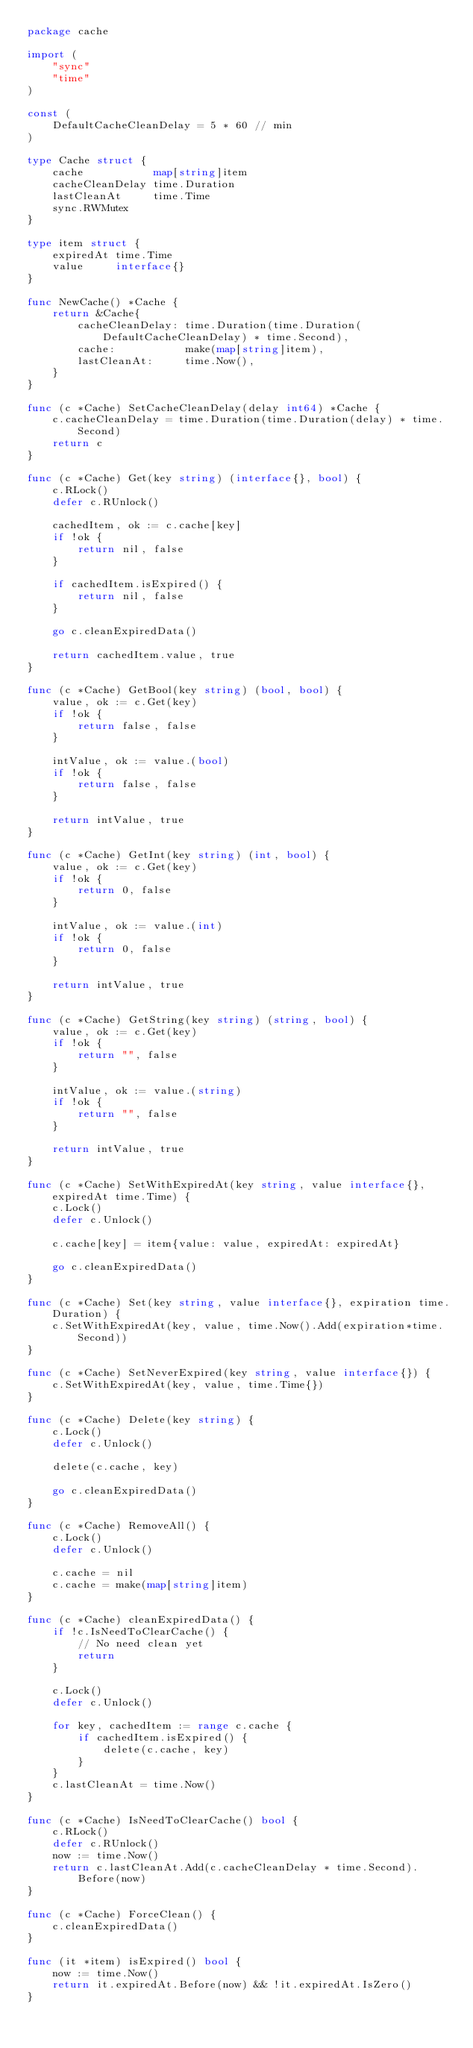Convert code to text. <code><loc_0><loc_0><loc_500><loc_500><_Go_>package cache

import (
	"sync"
	"time"
)

const (
	DefaultCacheCleanDelay = 5 * 60 // min
)

type Cache struct {
	cache           map[string]item
	cacheCleanDelay time.Duration
	lastCleanAt     time.Time
	sync.RWMutex
}

type item struct {
	expiredAt time.Time
	value     interface{}
}

func NewCache() *Cache {
	return &Cache{
		cacheCleanDelay: time.Duration(time.Duration(DefaultCacheCleanDelay) * time.Second),
		cache:           make(map[string]item),
		lastCleanAt:     time.Now(),
	}
}

func (c *Cache) SetCacheCleanDelay(delay int64) *Cache {
	c.cacheCleanDelay = time.Duration(time.Duration(delay) * time.Second)
	return c
}

func (c *Cache) Get(key string) (interface{}, bool) {
	c.RLock()
	defer c.RUnlock()

	cachedItem, ok := c.cache[key]
	if !ok {
		return nil, false
	}

	if cachedItem.isExpired() {
		return nil, false
	}

	go c.cleanExpiredData()

	return cachedItem.value, true
}

func (c *Cache) GetBool(key string) (bool, bool) {
	value, ok := c.Get(key)
	if !ok {
		return false, false
	}

	intValue, ok := value.(bool)
	if !ok {
		return false, false
	}

	return intValue, true
}

func (c *Cache) GetInt(key string) (int, bool) {
	value, ok := c.Get(key)
	if !ok {
		return 0, false
	}

	intValue, ok := value.(int)
	if !ok {
		return 0, false
	}

	return intValue, true
}

func (c *Cache) GetString(key string) (string, bool) {
	value, ok := c.Get(key)
	if !ok {
		return "", false
	}

	intValue, ok := value.(string)
	if !ok {
		return "", false
	}

	return intValue, true
}

func (c *Cache) SetWithExpiredAt(key string, value interface{}, expiredAt time.Time) {
	c.Lock()
	defer c.Unlock()

	c.cache[key] = item{value: value, expiredAt: expiredAt}

	go c.cleanExpiredData()
}

func (c *Cache) Set(key string, value interface{}, expiration time.Duration) {
	c.SetWithExpiredAt(key, value, time.Now().Add(expiration*time.Second))
}

func (c *Cache) SetNeverExpired(key string, value interface{}) {
	c.SetWithExpiredAt(key, value, time.Time{})
}

func (c *Cache) Delete(key string) {
	c.Lock()
	defer c.Unlock()

	delete(c.cache, key)

	go c.cleanExpiredData()
}

func (c *Cache) RemoveAll() {
	c.Lock()
	defer c.Unlock()

	c.cache = nil
	c.cache = make(map[string]item)
}

func (c *Cache) cleanExpiredData() {
	if !c.IsNeedToClearCache() {
		// No need clean yet
		return
	}

	c.Lock()
	defer c.Unlock()

	for key, cachedItem := range c.cache {
		if cachedItem.isExpired() {
			delete(c.cache, key)
		}
	}
	c.lastCleanAt = time.Now()
}

func (c *Cache) IsNeedToClearCache() bool {
	c.RLock()
	defer c.RUnlock()
	now := time.Now()
	return c.lastCleanAt.Add(c.cacheCleanDelay * time.Second).Before(now)
}

func (c *Cache) ForceClean() {
	c.cleanExpiredData()
}

func (it *item) isExpired() bool {
	now := time.Now()
	return it.expiredAt.Before(now) && !it.expiredAt.IsZero()
}
</code> 